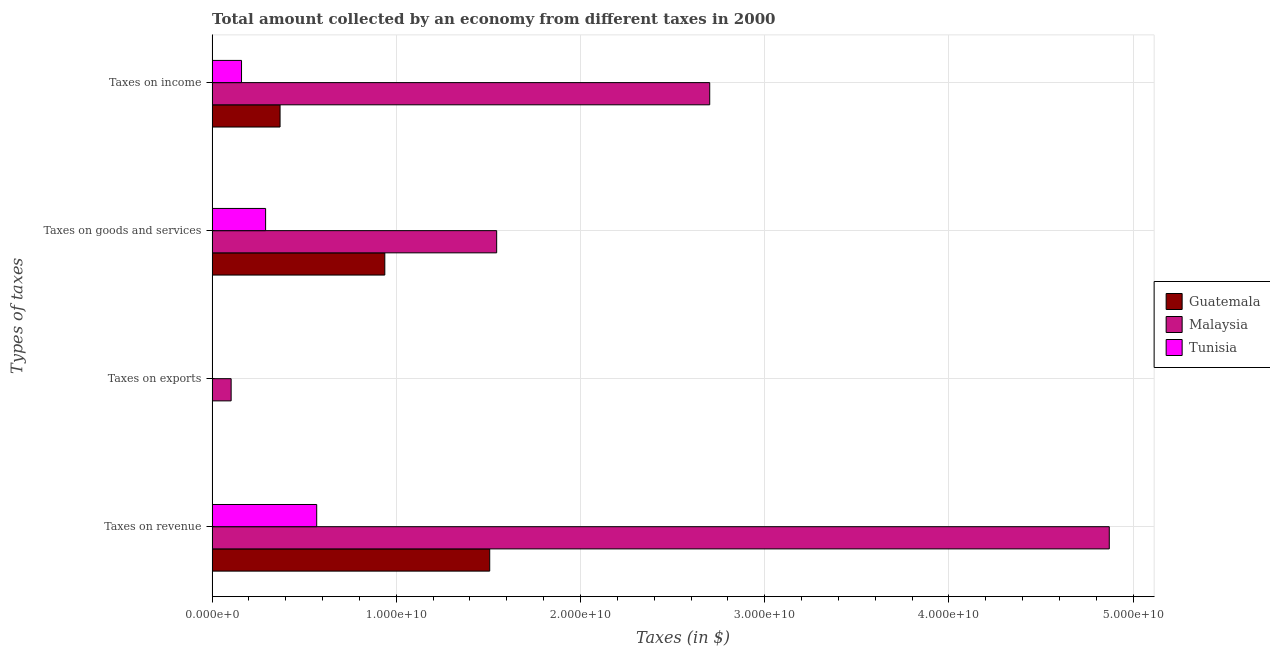How many different coloured bars are there?
Provide a short and direct response. 3. How many groups of bars are there?
Provide a short and direct response. 4. Are the number of bars per tick equal to the number of legend labels?
Keep it short and to the point. Yes. How many bars are there on the 4th tick from the bottom?
Give a very brief answer. 3. What is the label of the 3rd group of bars from the top?
Your answer should be very brief. Taxes on exports. What is the amount collected as tax on revenue in Tunisia?
Offer a terse response. 5.68e+09. Across all countries, what is the maximum amount collected as tax on revenue?
Provide a short and direct response. 4.87e+1. Across all countries, what is the minimum amount collected as tax on revenue?
Provide a succinct answer. 5.68e+09. In which country was the amount collected as tax on income maximum?
Give a very brief answer. Malaysia. In which country was the amount collected as tax on goods minimum?
Make the answer very short. Tunisia. What is the total amount collected as tax on goods in the graph?
Ensure brevity in your answer.  2.77e+1. What is the difference between the amount collected as tax on revenue in Malaysia and that in Tunisia?
Your response must be concise. 4.30e+1. What is the difference between the amount collected as tax on goods in Guatemala and the amount collected as tax on revenue in Tunisia?
Keep it short and to the point. 3.70e+09. What is the average amount collected as tax on exports per country?
Your response must be concise. 3.48e+08. What is the difference between the amount collected as tax on income and amount collected as tax on revenue in Guatemala?
Your answer should be very brief. -1.14e+1. In how many countries, is the amount collected as tax on exports greater than 8000000000 $?
Your answer should be compact. 0. What is the ratio of the amount collected as tax on income in Guatemala to that in Malaysia?
Offer a terse response. 0.14. Is the amount collected as tax on exports in Guatemala less than that in Tunisia?
Your answer should be very brief. Yes. What is the difference between the highest and the second highest amount collected as tax on exports?
Offer a very short reply. 1.02e+09. What is the difference between the highest and the lowest amount collected as tax on revenue?
Your response must be concise. 4.30e+1. In how many countries, is the amount collected as tax on exports greater than the average amount collected as tax on exports taken over all countries?
Ensure brevity in your answer.  1. Is the sum of the amount collected as tax on exports in Malaysia and Guatemala greater than the maximum amount collected as tax on income across all countries?
Keep it short and to the point. No. Is it the case that in every country, the sum of the amount collected as tax on income and amount collected as tax on exports is greater than the sum of amount collected as tax on revenue and amount collected as tax on goods?
Ensure brevity in your answer.  No. What does the 3rd bar from the top in Taxes on revenue represents?
Give a very brief answer. Guatemala. What does the 2nd bar from the bottom in Taxes on revenue represents?
Make the answer very short. Malaysia. Is it the case that in every country, the sum of the amount collected as tax on revenue and amount collected as tax on exports is greater than the amount collected as tax on goods?
Make the answer very short. Yes. Are the values on the major ticks of X-axis written in scientific E-notation?
Offer a terse response. Yes. Does the graph contain any zero values?
Provide a succinct answer. No. Does the graph contain grids?
Keep it short and to the point. Yes. Where does the legend appear in the graph?
Offer a terse response. Center right. How many legend labels are there?
Keep it short and to the point. 3. How are the legend labels stacked?
Provide a succinct answer. Vertical. What is the title of the graph?
Make the answer very short. Total amount collected by an economy from different taxes in 2000. What is the label or title of the X-axis?
Offer a terse response. Taxes (in $). What is the label or title of the Y-axis?
Your answer should be very brief. Types of taxes. What is the Taxes (in $) of Guatemala in Taxes on revenue?
Make the answer very short. 1.51e+1. What is the Taxes (in $) in Malaysia in Taxes on revenue?
Your answer should be compact. 4.87e+1. What is the Taxes (in $) in Tunisia in Taxes on revenue?
Offer a terse response. 5.68e+09. What is the Taxes (in $) of Guatemala in Taxes on exports?
Your answer should be very brief. 1.49e+06. What is the Taxes (in $) in Malaysia in Taxes on exports?
Your response must be concise. 1.03e+09. What is the Taxes (in $) of Tunisia in Taxes on exports?
Keep it short and to the point. 1.12e+07. What is the Taxes (in $) in Guatemala in Taxes on goods and services?
Provide a short and direct response. 9.38e+09. What is the Taxes (in $) in Malaysia in Taxes on goods and services?
Offer a terse response. 1.54e+1. What is the Taxes (in $) in Tunisia in Taxes on goods and services?
Your response must be concise. 2.90e+09. What is the Taxes (in $) of Guatemala in Taxes on income?
Make the answer very short. 3.69e+09. What is the Taxes (in $) of Malaysia in Taxes on income?
Keep it short and to the point. 2.70e+1. What is the Taxes (in $) of Tunisia in Taxes on income?
Give a very brief answer. 1.60e+09. Across all Types of taxes, what is the maximum Taxes (in $) in Guatemala?
Make the answer very short. 1.51e+1. Across all Types of taxes, what is the maximum Taxes (in $) in Malaysia?
Offer a terse response. 4.87e+1. Across all Types of taxes, what is the maximum Taxes (in $) in Tunisia?
Make the answer very short. 5.68e+09. Across all Types of taxes, what is the minimum Taxes (in $) of Guatemala?
Give a very brief answer. 1.49e+06. Across all Types of taxes, what is the minimum Taxes (in $) of Malaysia?
Provide a succinct answer. 1.03e+09. Across all Types of taxes, what is the minimum Taxes (in $) of Tunisia?
Give a very brief answer. 1.12e+07. What is the total Taxes (in $) in Guatemala in the graph?
Keep it short and to the point. 2.81e+1. What is the total Taxes (in $) of Malaysia in the graph?
Give a very brief answer. 9.22e+1. What is the total Taxes (in $) of Tunisia in the graph?
Make the answer very short. 1.02e+1. What is the difference between the Taxes (in $) in Guatemala in Taxes on revenue and that in Taxes on exports?
Provide a short and direct response. 1.51e+1. What is the difference between the Taxes (in $) of Malaysia in Taxes on revenue and that in Taxes on exports?
Your answer should be very brief. 4.77e+1. What is the difference between the Taxes (in $) in Tunisia in Taxes on revenue and that in Taxes on exports?
Provide a short and direct response. 5.67e+09. What is the difference between the Taxes (in $) of Guatemala in Taxes on revenue and that in Taxes on goods and services?
Keep it short and to the point. 5.70e+09. What is the difference between the Taxes (in $) in Malaysia in Taxes on revenue and that in Taxes on goods and services?
Your answer should be compact. 3.33e+1. What is the difference between the Taxes (in $) in Tunisia in Taxes on revenue and that in Taxes on goods and services?
Give a very brief answer. 2.77e+09. What is the difference between the Taxes (in $) in Guatemala in Taxes on revenue and that in Taxes on income?
Make the answer very short. 1.14e+1. What is the difference between the Taxes (in $) in Malaysia in Taxes on revenue and that in Taxes on income?
Your answer should be compact. 2.17e+1. What is the difference between the Taxes (in $) in Tunisia in Taxes on revenue and that in Taxes on income?
Keep it short and to the point. 4.08e+09. What is the difference between the Taxes (in $) of Guatemala in Taxes on exports and that in Taxes on goods and services?
Ensure brevity in your answer.  -9.37e+09. What is the difference between the Taxes (in $) of Malaysia in Taxes on exports and that in Taxes on goods and services?
Offer a very short reply. -1.44e+1. What is the difference between the Taxes (in $) in Tunisia in Taxes on exports and that in Taxes on goods and services?
Your response must be concise. -2.89e+09. What is the difference between the Taxes (in $) of Guatemala in Taxes on exports and that in Taxes on income?
Provide a short and direct response. -3.69e+09. What is the difference between the Taxes (in $) in Malaysia in Taxes on exports and that in Taxes on income?
Your answer should be very brief. -2.60e+1. What is the difference between the Taxes (in $) of Tunisia in Taxes on exports and that in Taxes on income?
Offer a very short reply. -1.59e+09. What is the difference between the Taxes (in $) of Guatemala in Taxes on goods and services and that in Taxes on income?
Your response must be concise. 5.69e+09. What is the difference between the Taxes (in $) of Malaysia in Taxes on goods and services and that in Taxes on income?
Offer a terse response. -1.16e+1. What is the difference between the Taxes (in $) in Tunisia in Taxes on goods and services and that in Taxes on income?
Your answer should be compact. 1.31e+09. What is the difference between the Taxes (in $) of Guatemala in Taxes on revenue and the Taxes (in $) of Malaysia in Taxes on exports?
Make the answer very short. 1.40e+1. What is the difference between the Taxes (in $) in Guatemala in Taxes on revenue and the Taxes (in $) in Tunisia in Taxes on exports?
Provide a succinct answer. 1.51e+1. What is the difference between the Taxes (in $) in Malaysia in Taxes on revenue and the Taxes (in $) in Tunisia in Taxes on exports?
Your answer should be compact. 4.87e+1. What is the difference between the Taxes (in $) of Guatemala in Taxes on revenue and the Taxes (in $) of Malaysia in Taxes on goods and services?
Provide a short and direct response. -3.77e+08. What is the difference between the Taxes (in $) in Guatemala in Taxes on revenue and the Taxes (in $) in Tunisia in Taxes on goods and services?
Keep it short and to the point. 1.22e+1. What is the difference between the Taxes (in $) of Malaysia in Taxes on revenue and the Taxes (in $) of Tunisia in Taxes on goods and services?
Provide a short and direct response. 4.58e+1. What is the difference between the Taxes (in $) in Guatemala in Taxes on revenue and the Taxes (in $) in Malaysia in Taxes on income?
Provide a succinct answer. -1.19e+1. What is the difference between the Taxes (in $) of Guatemala in Taxes on revenue and the Taxes (in $) of Tunisia in Taxes on income?
Provide a short and direct response. 1.35e+1. What is the difference between the Taxes (in $) in Malaysia in Taxes on revenue and the Taxes (in $) in Tunisia in Taxes on income?
Provide a short and direct response. 4.71e+1. What is the difference between the Taxes (in $) of Guatemala in Taxes on exports and the Taxes (in $) of Malaysia in Taxes on goods and services?
Provide a succinct answer. -1.54e+1. What is the difference between the Taxes (in $) of Guatemala in Taxes on exports and the Taxes (in $) of Tunisia in Taxes on goods and services?
Give a very brief answer. -2.90e+09. What is the difference between the Taxes (in $) of Malaysia in Taxes on exports and the Taxes (in $) of Tunisia in Taxes on goods and services?
Offer a very short reply. -1.87e+09. What is the difference between the Taxes (in $) of Guatemala in Taxes on exports and the Taxes (in $) of Malaysia in Taxes on income?
Your answer should be very brief. -2.70e+1. What is the difference between the Taxes (in $) in Guatemala in Taxes on exports and the Taxes (in $) in Tunisia in Taxes on income?
Provide a succinct answer. -1.60e+09. What is the difference between the Taxes (in $) of Malaysia in Taxes on exports and the Taxes (in $) of Tunisia in Taxes on income?
Your answer should be compact. -5.64e+08. What is the difference between the Taxes (in $) of Guatemala in Taxes on goods and services and the Taxes (in $) of Malaysia in Taxes on income?
Provide a succinct answer. -1.76e+1. What is the difference between the Taxes (in $) of Guatemala in Taxes on goods and services and the Taxes (in $) of Tunisia in Taxes on income?
Your answer should be compact. 7.78e+09. What is the difference between the Taxes (in $) of Malaysia in Taxes on goods and services and the Taxes (in $) of Tunisia in Taxes on income?
Your response must be concise. 1.39e+1. What is the average Taxes (in $) of Guatemala per Types of taxes?
Keep it short and to the point. 7.03e+09. What is the average Taxes (in $) of Malaysia per Types of taxes?
Ensure brevity in your answer.  2.31e+1. What is the average Taxes (in $) in Tunisia per Types of taxes?
Keep it short and to the point. 2.55e+09. What is the difference between the Taxes (in $) of Guatemala and Taxes (in $) of Malaysia in Taxes on revenue?
Provide a succinct answer. -3.36e+1. What is the difference between the Taxes (in $) of Guatemala and Taxes (in $) of Tunisia in Taxes on revenue?
Keep it short and to the point. 9.39e+09. What is the difference between the Taxes (in $) in Malaysia and Taxes (in $) in Tunisia in Taxes on revenue?
Your response must be concise. 4.30e+1. What is the difference between the Taxes (in $) of Guatemala and Taxes (in $) of Malaysia in Taxes on exports?
Give a very brief answer. -1.03e+09. What is the difference between the Taxes (in $) in Guatemala and Taxes (in $) in Tunisia in Taxes on exports?
Give a very brief answer. -9.71e+06. What is the difference between the Taxes (in $) of Malaysia and Taxes (in $) of Tunisia in Taxes on exports?
Offer a very short reply. 1.02e+09. What is the difference between the Taxes (in $) of Guatemala and Taxes (in $) of Malaysia in Taxes on goods and services?
Your response must be concise. -6.07e+09. What is the difference between the Taxes (in $) in Guatemala and Taxes (in $) in Tunisia in Taxes on goods and services?
Offer a very short reply. 6.47e+09. What is the difference between the Taxes (in $) in Malaysia and Taxes (in $) in Tunisia in Taxes on goods and services?
Offer a terse response. 1.25e+1. What is the difference between the Taxes (in $) of Guatemala and Taxes (in $) of Malaysia in Taxes on income?
Your answer should be very brief. -2.33e+1. What is the difference between the Taxes (in $) in Guatemala and Taxes (in $) in Tunisia in Taxes on income?
Your answer should be very brief. 2.09e+09. What is the difference between the Taxes (in $) in Malaysia and Taxes (in $) in Tunisia in Taxes on income?
Give a very brief answer. 2.54e+1. What is the ratio of the Taxes (in $) in Guatemala in Taxes on revenue to that in Taxes on exports?
Ensure brevity in your answer.  1.01e+04. What is the ratio of the Taxes (in $) in Malaysia in Taxes on revenue to that in Taxes on exports?
Your answer should be very brief. 47.18. What is the ratio of the Taxes (in $) in Tunisia in Taxes on revenue to that in Taxes on exports?
Your answer should be compact. 507. What is the ratio of the Taxes (in $) in Guatemala in Taxes on revenue to that in Taxes on goods and services?
Your answer should be very brief. 1.61. What is the ratio of the Taxes (in $) in Malaysia in Taxes on revenue to that in Taxes on goods and services?
Ensure brevity in your answer.  3.15. What is the ratio of the Taxes (in $) of Tunisia in Taxes on revenue to that in Taxes on goods and services?
Ensure brevity in your answer.  1.96. What is the ratio of the Taxes (in $) in Guatemala in Taxes on revenue to that in Taxes on income?
Your answer should be compact. 4.09. What is the ratio of the Taxes (in $) in Malaysia in Taxes on revenue to that in Taxes on income?
Offer a very short reply. 1.8. What is the ratio of the Taxes (in $) of Tunisia in Taxes on revenue to that in Taxes on income?
Make the answer very short. 3.56. What is the ratio of the Taxes (in $) in Malaysia in Taxes on exports to that in Taxes on goods and services?
Your answer should be very brief. 0.07. What is the ratio of the Taxes (in $) of Tunisia in Taxes on exports to that in Taxes on goods and services?
Provide a succinct answer. 0. What is the ratio of the Taxes (in $) in Malaysia in Taxes on exports to that in Taxes on income?
Make the answer very short. 0.04. What is the ratio of the Taxes (in $) of Tunisia in Taxes on exports to that in Taxes on income?
Give a very brief answer. 0.01. What is the ratio of the Taxes (in $) in Guatemala in Taxes on goods and services to that in Taxes on income?
Your response must be concise. 2.54. What is the ratio of the Taxes (in $) in Malaysia in Taxes on goods and services to that in Taxes on income?
Ensure brevity in your answer.  0.57. What is the ratio of the Taxes (in $) of Tunisia in Taxes on goods and services to that in Taxes on income?
Keep it short and to the point. 1.82. What is the difference between the highest and the second highest Taxes (in $) of Guatemala?
Offer a terse response. 5.70e+09. What is the difference between the highest and the second highest Taxes (in $) of Malaysia?
Provide a short and direct response. 2.17e+1. What is the difference between the highest and the second highest Taxes (in $) in Tunisia?
Provide a succinct answer. 2.77e+09. What is the difference between the highest and the lowest Taxes (in $) in Guatemala?
Give a very brief answer. 1.51e+1. What is the difference between the highest and the lowest Taxes (in $) of Malaysia?
Provide a short and direct response. 4.77e+1. What is the difference between the highest and the lowest Taxes (in $) in Tunisia?
Your response must be concise. 5.67e+09. 